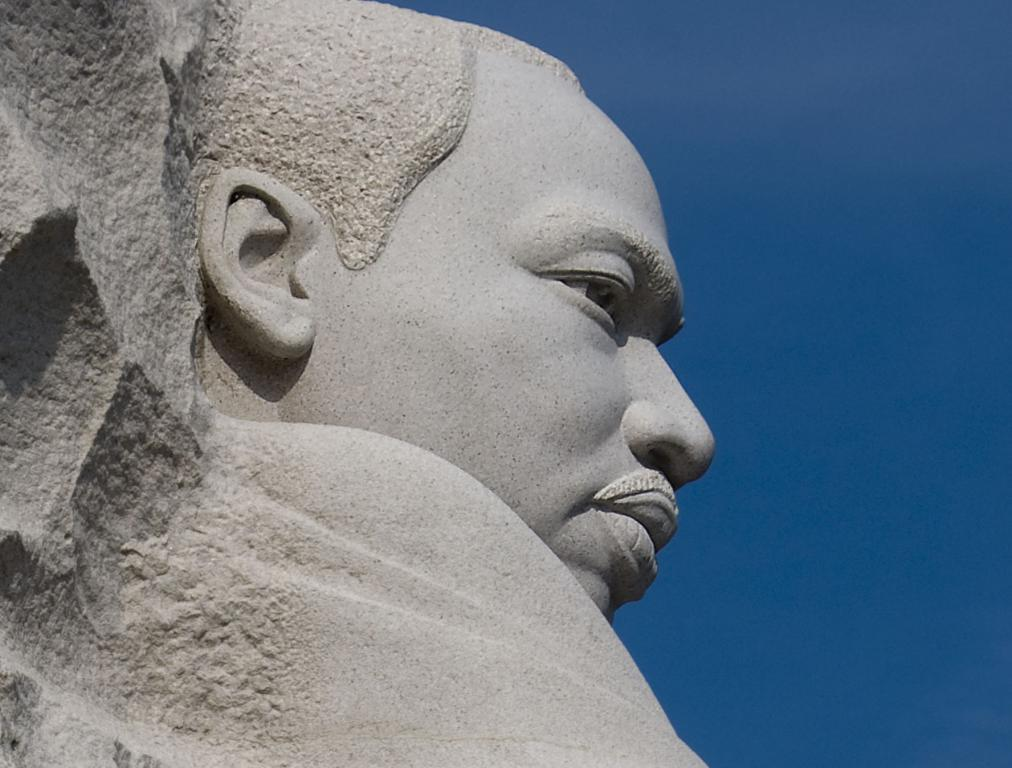What is the main subject of the image? The main subject of the image is a sculpture. Can you describe the sculpture in the image? The sculpture is of a man, and it is made up of cement. How many letters are visible on the sculpture in the image? There are no letters visible on the sculpture in the image; it is made of cement and represents a man. 